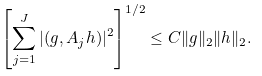Convert formula to latex. <formula><loc_0><loc_0><loc_500><loc_500>\left [ \sum _ { j = 1 } ^ { J } | ( g , A _ { j } h ) | ^ { 2 } \right ] ^ { 1 / 2 } \leq C \| g \| _ { 2 } \| h \| _ { 2 } .</formula> 